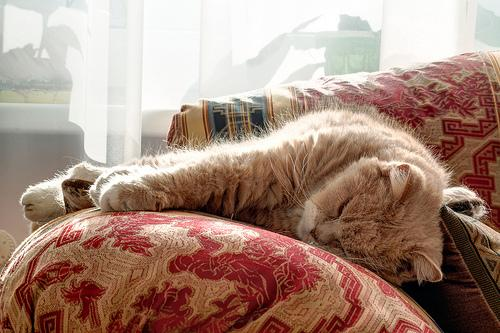Which object is behind the sleeping cat? A pillow is behind the sleeping cat. What does the cat appear to be doing, and how would you describe its appearance? The cat is sleeping and appears to have fluffy yellow fur, white paws, and brown ears. Identify three major elements in the image. A sleeping yellow and white cat, a red and beige patterned sofa, and sunlight coming through a sheer curtain. Identify any objects located near the window and describe their appearance. There is a sheer curtain on the window with white window shades and a plant on the seal. Summarize the scene captured in the image. A fluffy yellow and white cat is sleeping on a red and beige patterned sofa under the sun, with its head on a pillow. Perform a sentiment analysis of the image. The image conveys a sense of warmth, comfort, and relaxation, as the cat is peacefully sleeping on the sofa under sunlight. How many pillows are mentioned in the image, and what are their characteristics? There are two pillows mentioned: one behind the sleeping cat, which is red and flowered, and the other is a patterned throw pillow on the couch. Outline any distinctive features of the sofa. The sofa has a red and beige color, intricate patterns, and blue stripes. What color are the cat's ears and paws? The cat's ears are brown, and its paws are white. Describe the weather outside as suggested by the image. It is sunny outside, with sunlight shining through the window. 